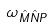Convert formula to latex. <formula><loc_0><loc_0><loc_500><loc_500>\omega _ { \hat { M } \hat { N } P }</formula> 